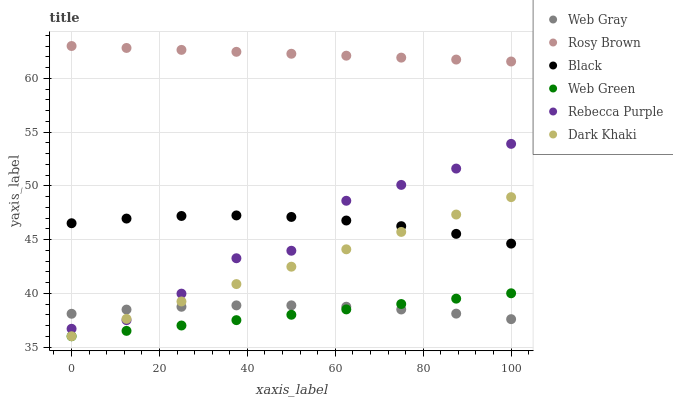Does Web Green have the minimum area under the curve?
Answer yes or no. Yes. Does Rosy Brown have the maximum area under the curve?
Answer yes or no. Yes. Does Rosy Brown have the minimum area under the curve?
Answer yes or no. No. Does Web Green have the maximum area under the curve?
Answer yes or no. No. Is Rosy Brown the smoothest?
Answer yes or no. Yes. Is Rebecca Purple the roughest?
Answer yes or no. Yes. Is Web Green the smoothest?
Answer yes or no. No. Is Web Green the roughest?
Answer yes or no. No. Does Web Green have the lowest value?
Answer yes or no. Yes. Does Rosy Brown have the lowest value?
Answer yes or no. No. Does Rosy Brown have the highest value?
Answer yes or no. Yes. Does Web Green have the highest value?
Answer yes or no. No. Is Web Green less than Rosy Brown?
Answer yes or no. Yes. Is Rebecca Purple greater than Web Green?
Answer yes or no. Yes. Does Rebecca Purple intersect Dark Khaki?
Answer yes or no. Yes. Is Rebecca Purple less than Dark Khaki?
Answer yes or no. No. Is Rebecca Purple greater than Dark Khaki?
Answer yes or no. No. Does Web Green intersect Rosy Brown?
Answer yes or no. No. 